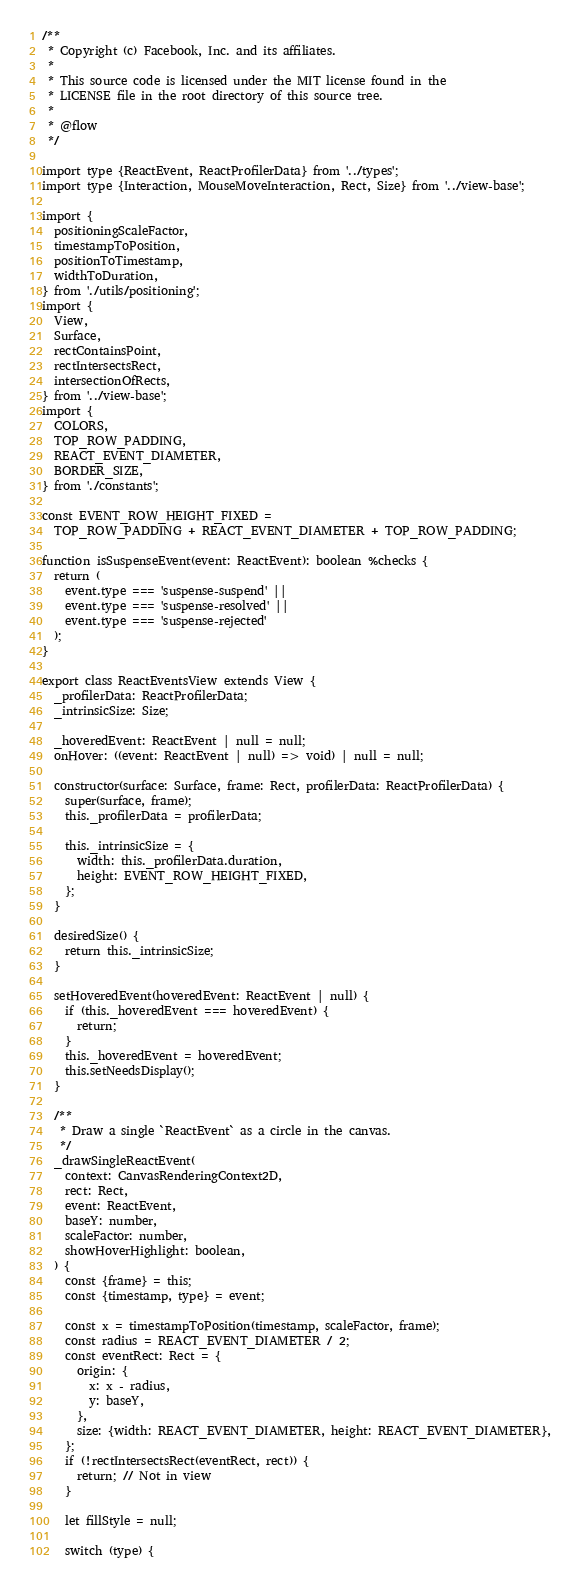Convert code to text. <code><loc_0><loc_0><loc_500><loc_500><_JavaScript_>/**
 * Copyright (c) Facebook, Inc. and its affiliates.
 *
 * This source code is licensed under the MIT license found in the
 * LICENSE file in the root directory of this source tree.
 *
 * @flow
 */

import type {ReactEvent, ReactProfilerData} from '../types';
import type {Interaction, MouseMoveInteraction, Rect, Size} from '../view-base';

import {
  positioningScaleFactor,
  timestampToPosition,
  positionToTimestamp,
  widthToDuration,
} from './utils/positioning';
import {
  View,
  Surface,
  rectContainsPoint,
  rectIntersectsRect,
  intersectionOfRects,
} from '../view-base';
import {
  COLORS,
  TOP_ROW_PADDING,
  REACT_EVENT_DIAMETER,
  BORDER_SIZE,
} from './constants';

const EVENT_ROW_HEIGHT_FIXED =
  TOP_ROW_PADDING + REACT_EVENT_DIAMETER + TOP_ROW_PADDING;

function isSuspenseEvent(event: ReactEvent): boolean %checks {
  return (
    event.type === 'suspense-suspend' ||
    event.type === 'suspense-resolved' ||
    event.type === 'suspense-rejected'
  );
}

export class ReactEventsView extends View {
  _profilerData: ReactProfilerData;
  _intrinsicSize: Size;

  _hoveredEvent: ReactEvent | null = null;
  onHover: ((event: ReactEvent | null) => void) | null = null;

  constructor(surface: Surface, frame: Rect, profilerData: ReactProfilerData) {
    super(surface, frame);
    this._profilerData = profilerData;

    this._intrinsicSize = {
      width: this._profilerData.duration,
      height: EVENT_ROW_HEIGHT_FIXED,
    };
  }

  desiredSize() {
    return this._intrinsicSize;
  }

  setHoveredEvent(hoveredEvent: ReactEvent | null) {
    if (this._hoveredEvent === hoveredEvent) {
      return;
    }
    this._hoveredEvent = hoveredEvent;
    this.setNeedsDisplay();
  }

  /**
   * Draw a single `ReactEvent` as a circle in the canvas.
   */
  _drawSingleReactEvent(
    context: CanvasRenderingContext2D,
    rect: Rect,
    event: ReactEvent,
    baseY: number,
    scaleFactor: number,
    showHoverHighlight: boolean,
  ) {
    const {frame} = this;
    const {timestamp, type} = event;

    const x = timestampToPosition(timestamp, scaleFactor, frame);
    const radius = REACT_EVENT_DIAMETER / 2;
    const eventRect: Rect = {
      origin: {
        x: x - radius,
        y: baseY,
      },
      size: {width: REACT_EVENT_DIAMETER, height: REACT_EVENT_DIAMETER},
    };
    if (!rectIntersectsRect(eventRect, rect)) {
      return; // Not in view
    }

    let fillStyle = null;

    switch (type) {</code> 